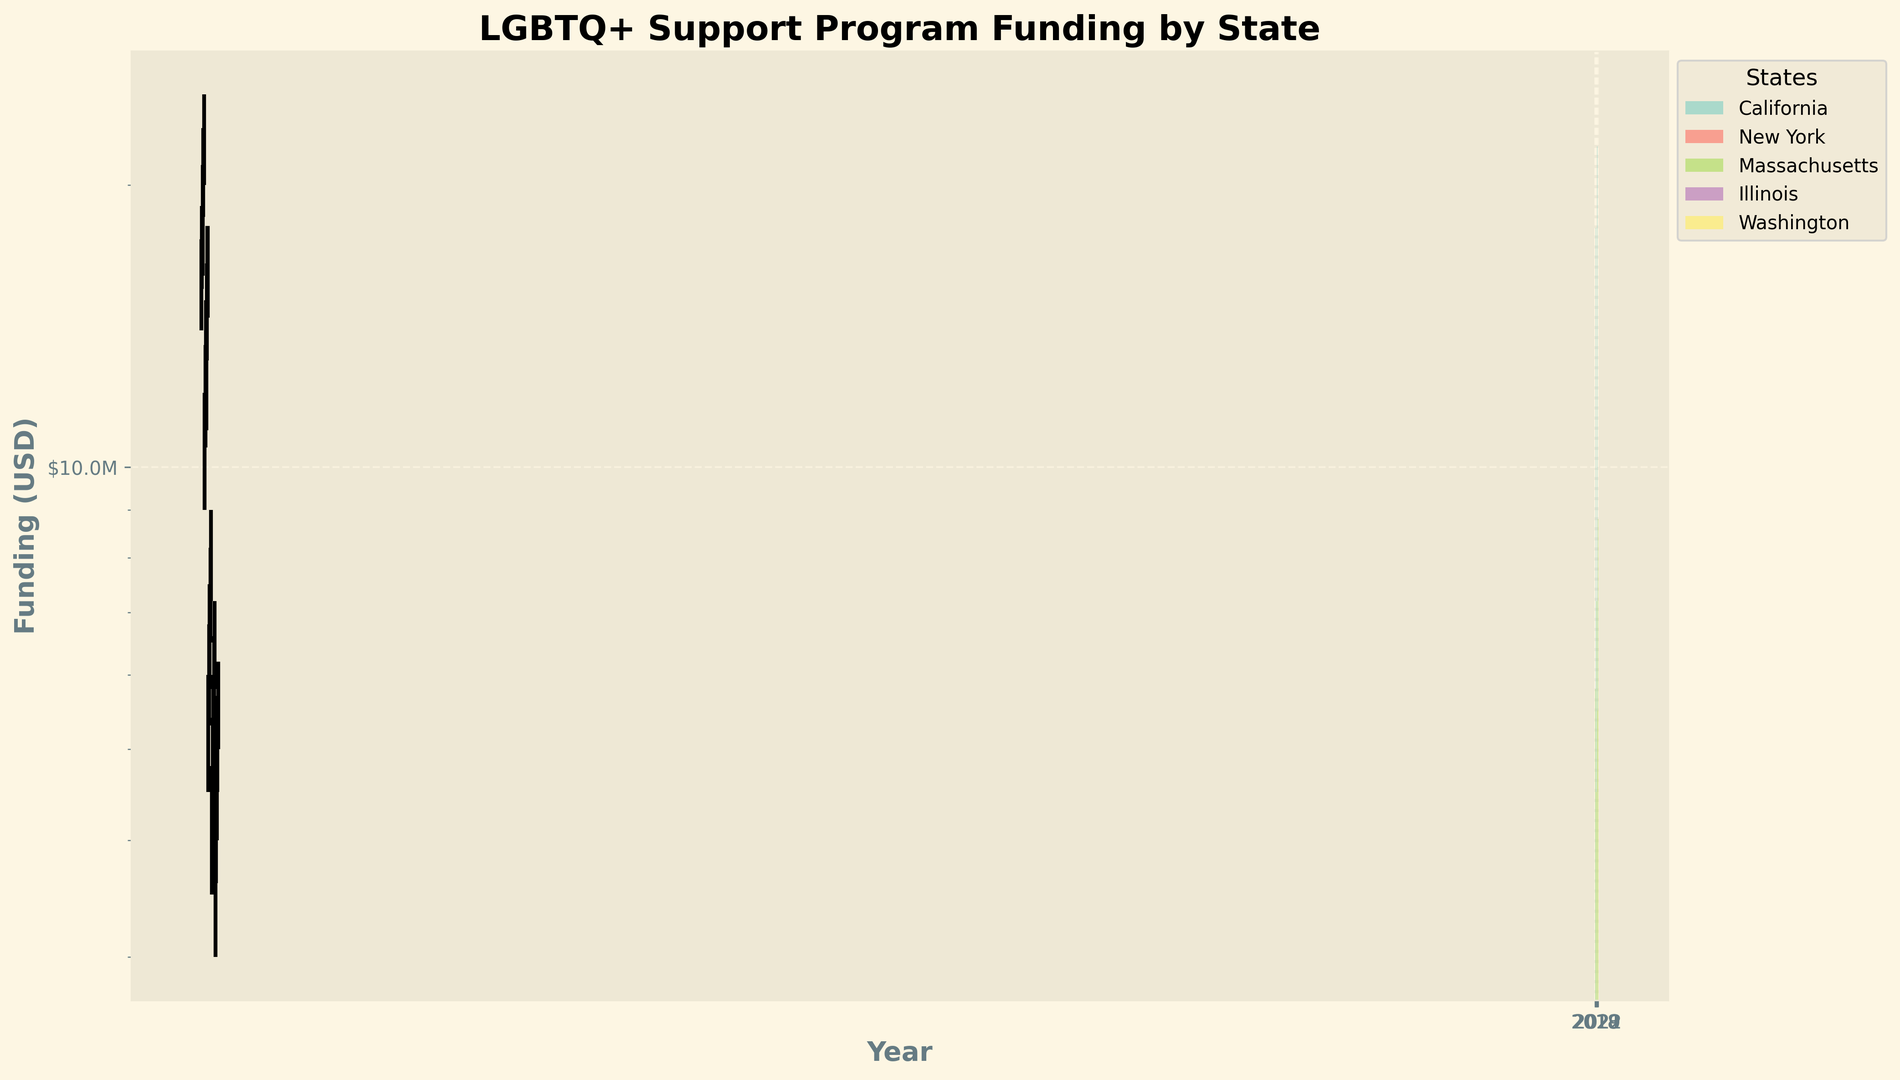Which state had the highest funding allocated to LGBTQ+ support programs in 2022? The highest funding in 2022 is indicated by the tallest bar. The bar representing California is the tallest for the year 2022.
Answer: California What was the difference in 2021 funding between New York and Massachusetts? Look at the "Close" value for 2021 for both New York and Massachusetts. New York's is $16,000,000, and Massachusetts's is $8,000,000. The difference is $16,000,000 - $8,000,000.
Answer: $8,000,000 Which state's funding showed the most significant increase from 2018 to 2022? Look at the "Close" values for 2018 and 2022 for all states and calculate the differences: California ($24,000,000 - $16,500,000 = $7,500,000), New York ($17,500,000 - $11,500,000 = $6,000,000), Massachusetts ($8,800,000 - $5,800,000 = $3,000,000), Illinois ($7,000,000 - $4,600,000 = $2,400,000), Washington ($6,000,000 - $4,000,000 = $2,000,000). California has the most significant increase.
Answer: California In 2020, which state had the lowest minimum funding, and what was that amount? Look at the "Low" value for 2020 for all states. The lowest "Low" value is for Washington at $4,000,000.
Answer: Washington, $4,000,000 What is the average closing value for Massachusetts from 2018 to 2022? Calculate the sum of the "Close" values for Massachusetts from 2018 to 2022 and divide by 5: ($5,800,000 + $6,500,000 + $7,200,000 + $8,000,000 + $8,800,000) / 5.
Answer: $7,260,000 Is the funding trend for Illinois more consistent compared to Washington from 2018 to 2022? Observe the yearly "Close" values for both Illinois and Washington from 2018 to 2022. Illinois has smaller increments ($4,600,000, $5,200,000, $5,800,000, $6,400,000, $7,000,000) compared to Washington ($4,000,000, $4,500,000, $5,000,000, $5,500,000, $6,000,000). Therefore, Illinois has a more consistent trend.
Answer: Yes Between which two consecutive years did California see the highest increase in funding? Compare the differences in "Close" values between consecutive years for California. The differences are: 2019-2018 ($18,000,000 - $16,500,000 = $1,500,000), 2020-2019 ($20,000,000 - $18,000,000 = $2,000,000), 2021-2020 ($22,000,000 - $20,000,000 = $2,000,000), 2022-2021 ($24,000,000 - $22,000,000 = $2,000,000). The highest increase is $2,000,000, occurring between 2020-2021 and 2021-2022.
Answer: 2020-2021 or 2021-2022 Which state's funding remained above $5,000,000 from 2018 to 2022 without dropping below this mark? Check the "Low" values for each year for all states and find any that never drop below $5,000,000. Only Massachusetts and Illinois maintained funding above $5,000,000; however, Illinois starts below in 2018.
Answer: Massachusetts 